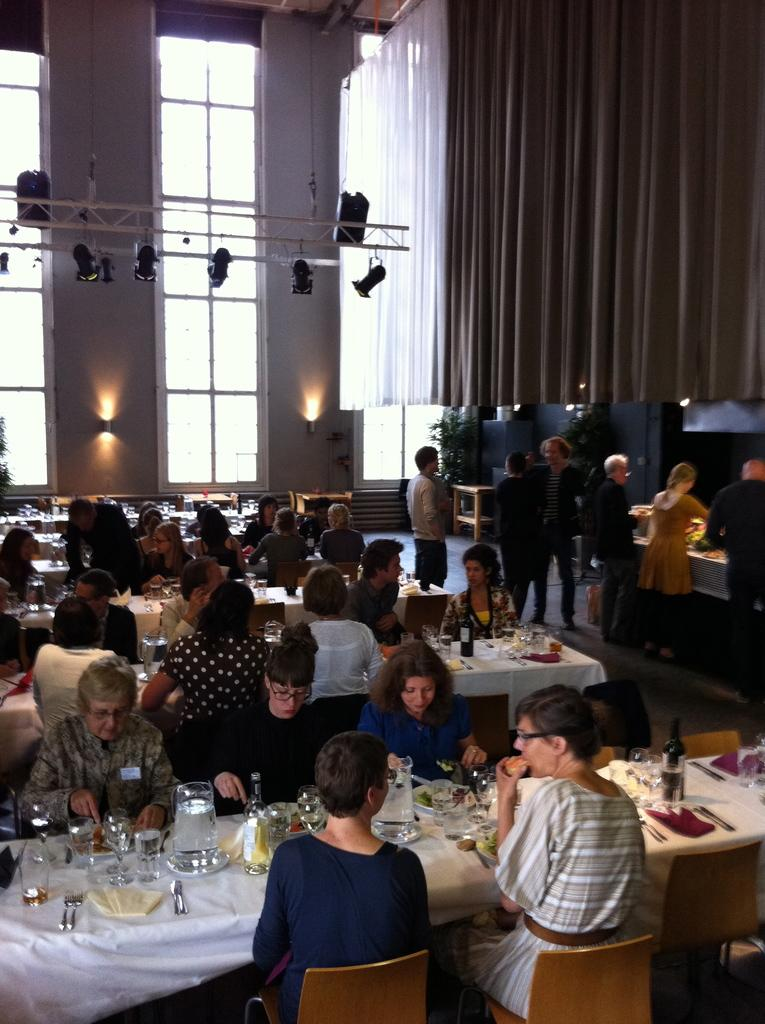How many people are in the image? There is a group of people in the image, but the exact number is not specified. What are the people doing in the image? The people are sitting in front of a table. What can be seen on the table? There are food vessels on the table. What is visible at the back of the image? There are lights and a curtain visible at the back of the image. What type of oil is being used to lubricate the elbows of the people in the image? There is no mention of oil or elbows in the image; the people are sitting at a table with food vessels. Can you tell me how many airplanes are visible in the image? There is no mention of an airport or airplanes in the image; it features a group of people sitting at a table with food vessels. 